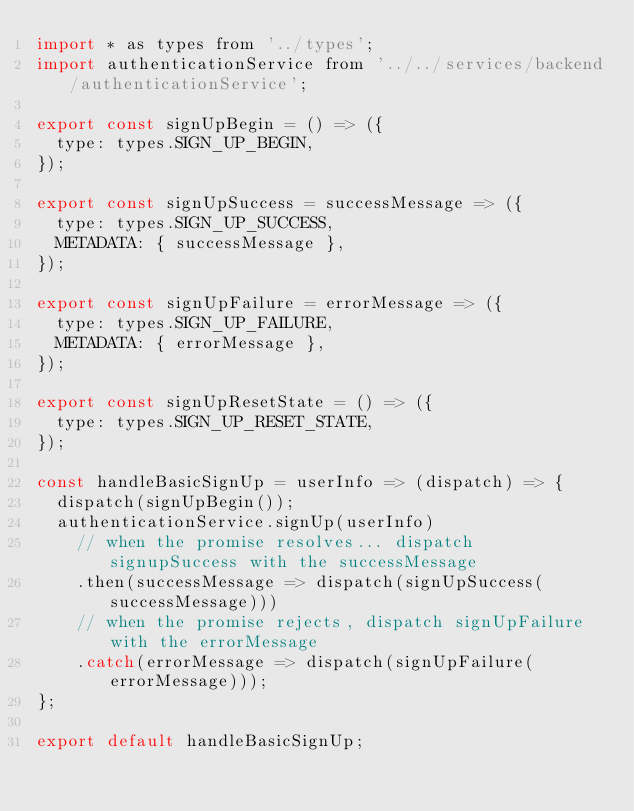<code> <loc_0><loc_0><loc_500><loc_500><_JavaScript_>import * as types from '../types';
import authenticationService from '../../services/backend/authenticationService';

export const signUpBegin = () => ({
  type: types.SIGN_UP_BEGIN,
});

export const signUpSuccess = successMessage => ({
  type: types.SIGN_UP_SUCCESS,
  METADATA: { successMessage },
});

export const signUpFailure = errorMessage => ({
  type: types.SIGN_UP_FAILURE,
  METADATA: { errorMessage },
});

export const signUpResetState = () => ({
  type: types.SIGN_UP_RESET_STATE,
});

const handleBasicSignUp = userInfo => (dispatch) => {
  dispatch(signUpBegin());
  authenticationService.signUp(userInfo)
    // when the promise resolves... dispatch signupSuccess with the successMessage
    .then(successMessage => dispatch(signUpSuccess(successMessage)))
    // when the promise rejects, dispatch signUpFailure with the errorMessage
    .catch(errorMessage => dispatch(signUpFailure(errorMessage)));
};

export default handleBasicSignUp;
</code> 